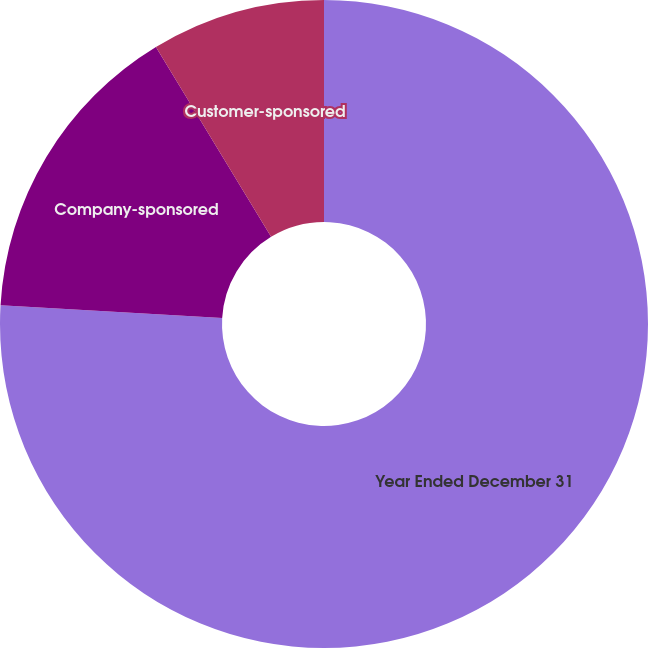Convert chart. <chart><loc_0><loc_0><loc_500><loc_500><pie_chart><fcel>Year Ended December 31<fcel>Company-sponsored<fcel>Customer-sponsored<nl><fcel>75.92%<fcel>15.4%<fcel>8.68%<nl></chart> 